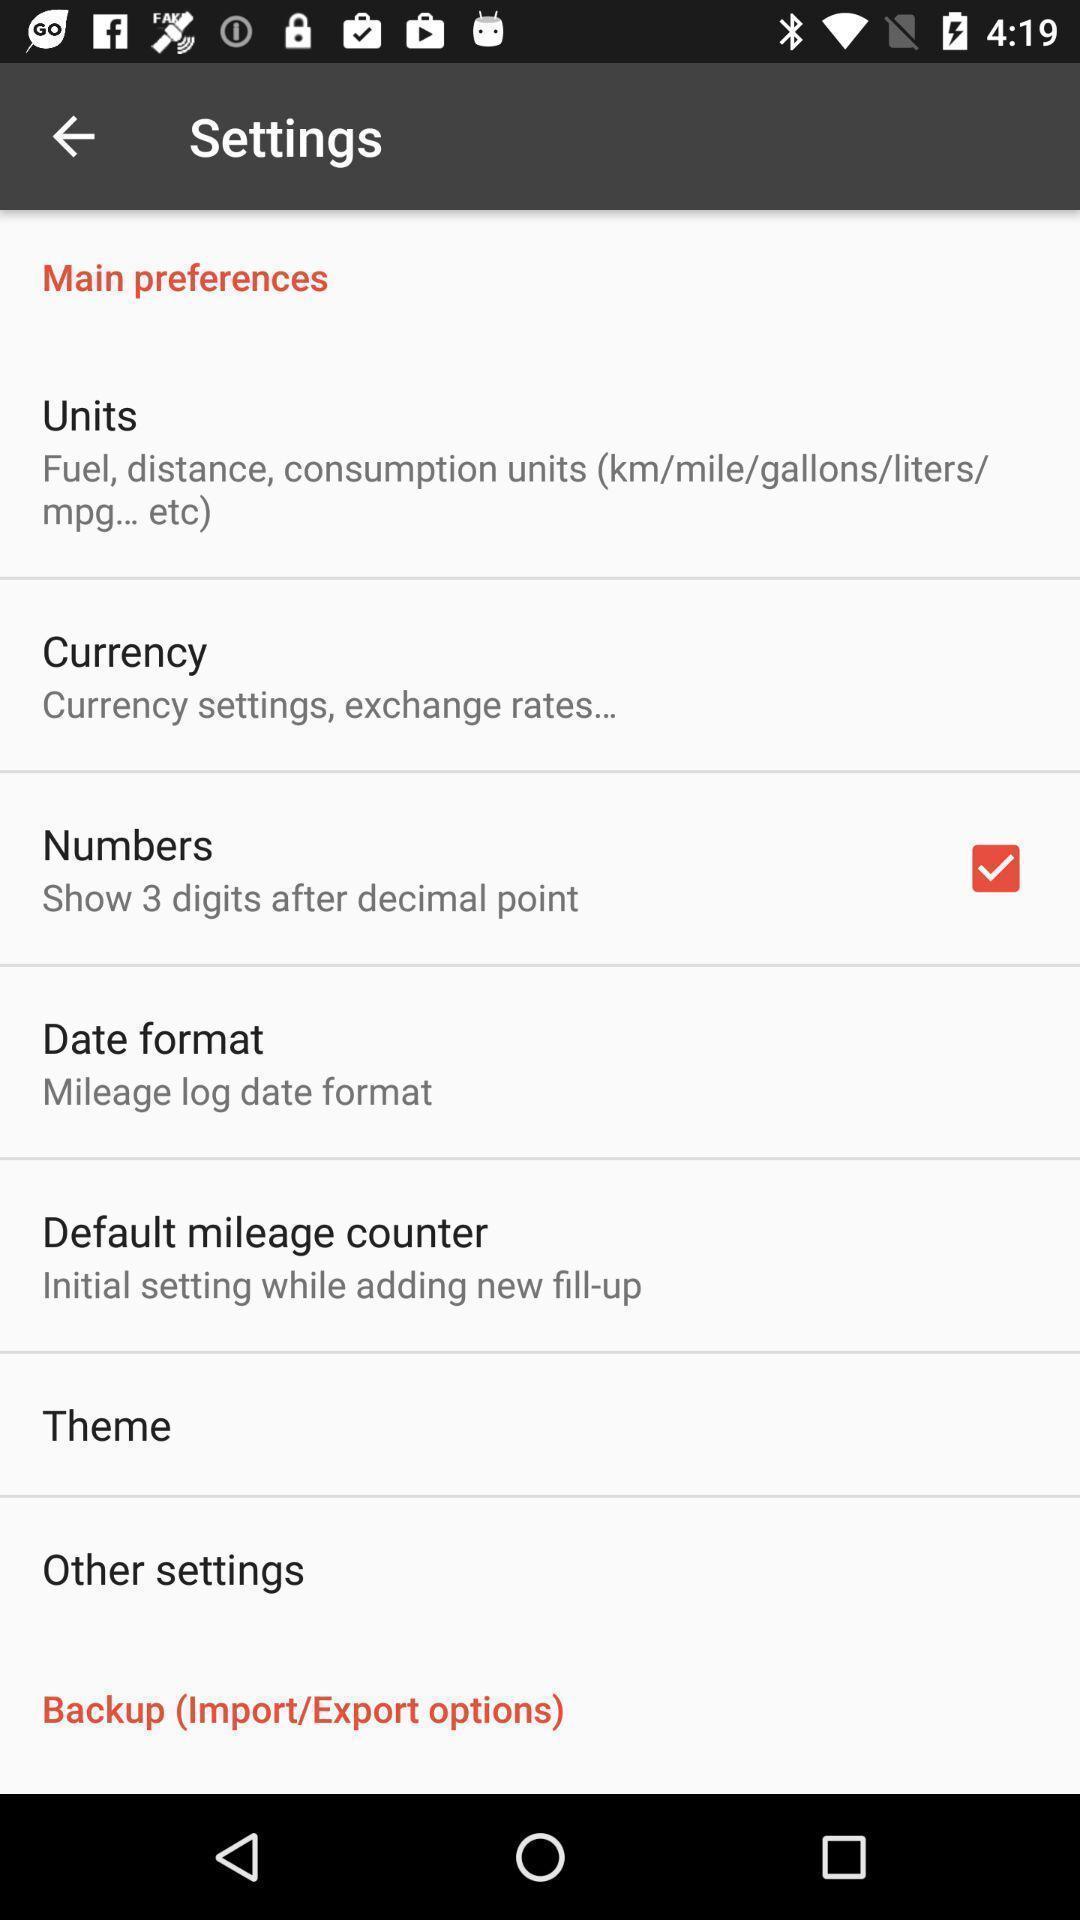Explain what's happening in this screen capture. Screen displaying the settings page. 